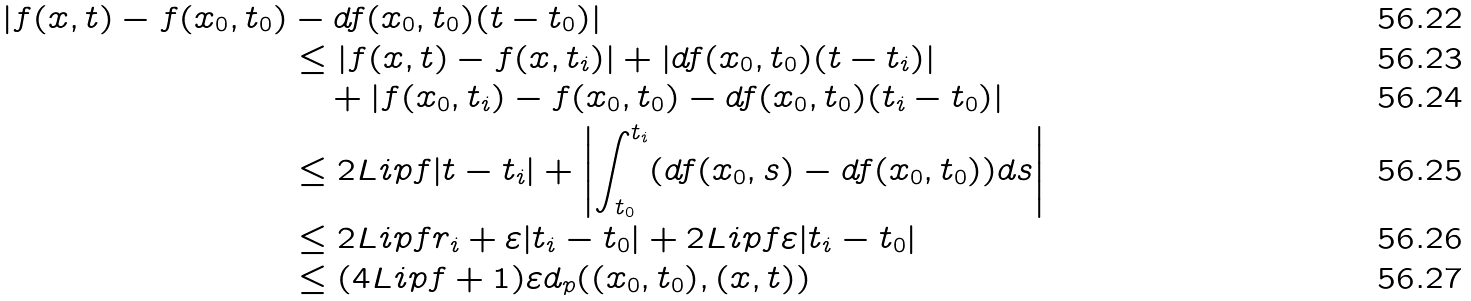<formula> <loc_0><loc_0><loc_500><loc_500>| f ( x , t ) - f ( x _ { 0 } , t _ { 0 } ) & - d f ( x _ { 0 } , t _ { 0 } ) ( t - t _ { 0 } ) | \\ & \leq | f ( x , t ) - f ( x , t _ { i } ) | + | d f ( x _ { 0 } , t _ { 0 } ) ( t - t _ { i } ) | \\ & \quad + | f ( x _ { 0 } , t _ { i } ) - f ( x _ { 0 } , t _ { 0 } ) - d f ( x _ { 0 } , t _ { 0 } ) ( t _ { i } - t _ { 0 } ) | \\ & \leq 2 L i p f | t - t _ { i } | + \left | \int _ { t _ { 0 } } ^ { t _ { i } } ( d f ( x _ { 0 } , s ) - d f ( x _ { 0 } , t _ { 0 } ) ) d s \right | \\ & \leq 2 L i p f r _ { i } + \varepsilon | t _ { i } - t _ { 0 } | + 2 L i p f \varepsilon | t _ { i } - t _ { 0 } | \\ & \leq ( 4 L i p f + 1 ) \varepsilon d _ { p } ( ( x _ { 0 } , t _ { 0 } ) , ( x , t ) )</formula> 